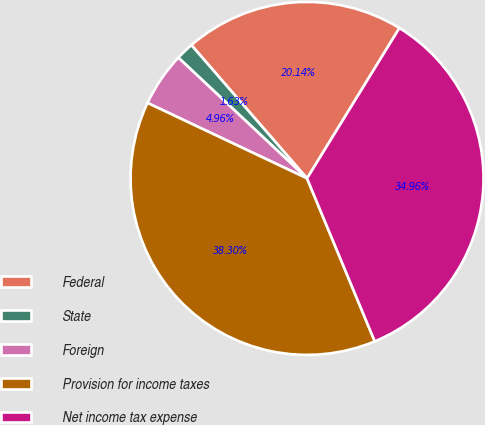<chart> <loc_0><loc_0><loc_500><loc_500><pie_chart><fcel>Federal<fcel>State<fcel>Foreign<fcel>Provision for income taxes<fcel>Net income tax expense<nl><fcel>20.14%<fcel>1.63%<fcel>4.96%<fcel>38.3%<fcel>34.96%<nl></chart> 